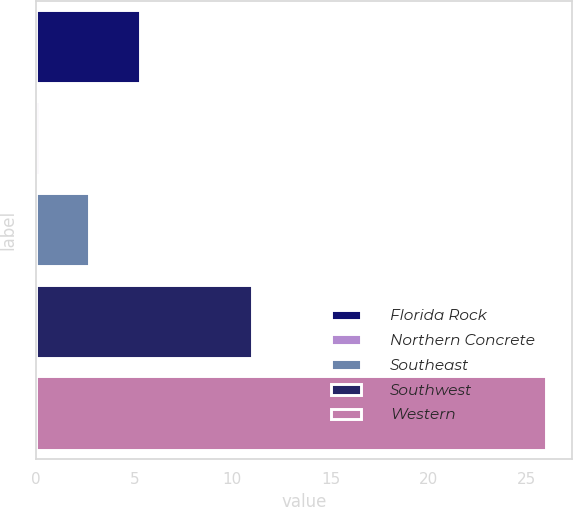Convert chart. <chart><loc_0><loc_0><loc_500><loc_500><bar_chart><fcel>Florida Rock<fcel>Northern Concrete<fcel>Southeast<fcel>Southwest<fcel>Western<nl><fcel>5.3<fcel>0.12<fcel>2.71<fcel>11<fcel>26<nl></chart> 